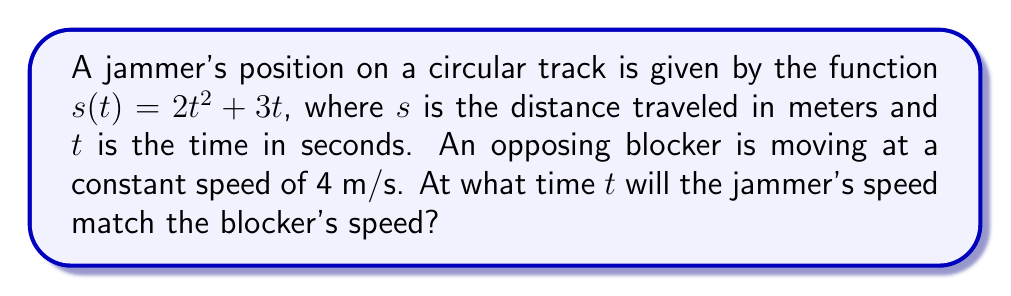Solve this math problem. To solve this problem, we need to follow these steps:

1) First, we need to find the jammer's speed function. Speed is the rate of change of position, which is the first derivative of the position function.

   $s(t) = 2t^2 + 3t$
   $s'(t) = 4t + 3$ (This is the jammer's speed function)

2) We want to find when this speed equals the blocker's constant speed of 4 m/s. So we set up the equation:

   $4t + 3 = 4$

3) Now we solve this equation for $t$:

   $4t = 1$
   $t = \frac{1}{4} = 0.25$

4) To verify, we can check the jammer's speed at $t = 0.25$ seconds:

   $s'(0.25) = 4(0.25) + 3 = 1 + 3 = 4$ m/s

This confirms that at $t = 0.25$ seconds, the jammer's speed matches the blocker's speed of 4 m/s.
Answer: $t = 0.25$ seconds 